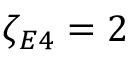Convert formula to latex. <formula><loc_0><loc_0><loc_500><loc_500>\zeta _ { E 4 } = 2</formula> 